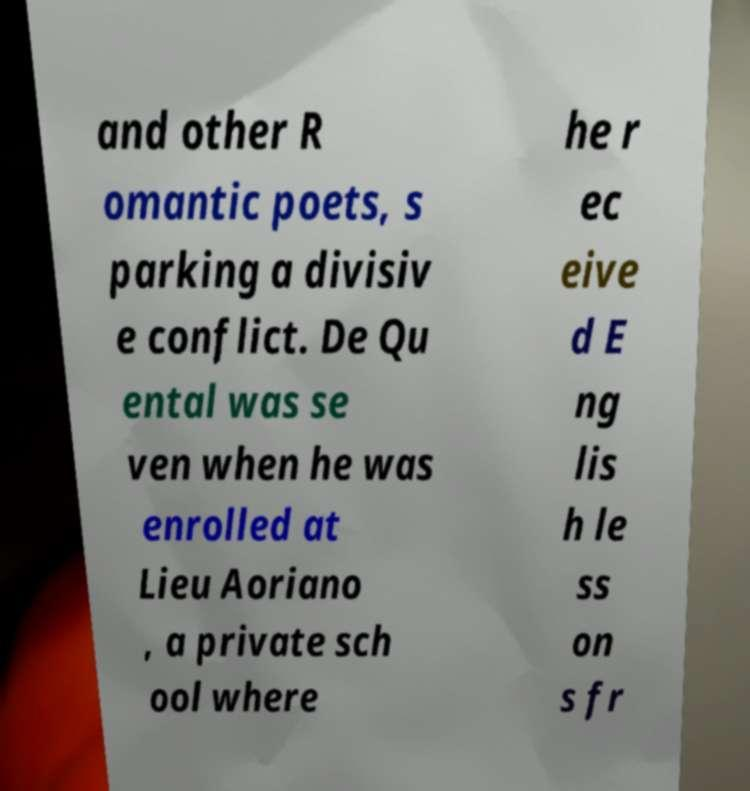What messages or text are displayed in this image? I need them in a readable, typed format. and other R omantic poets, s parking a divisiv e conflict. De Qu ental was se ven when he was enrolled at Lieu Aoriano , a private sch ool where he r ec eive d E ng lis h le ss on s fr 